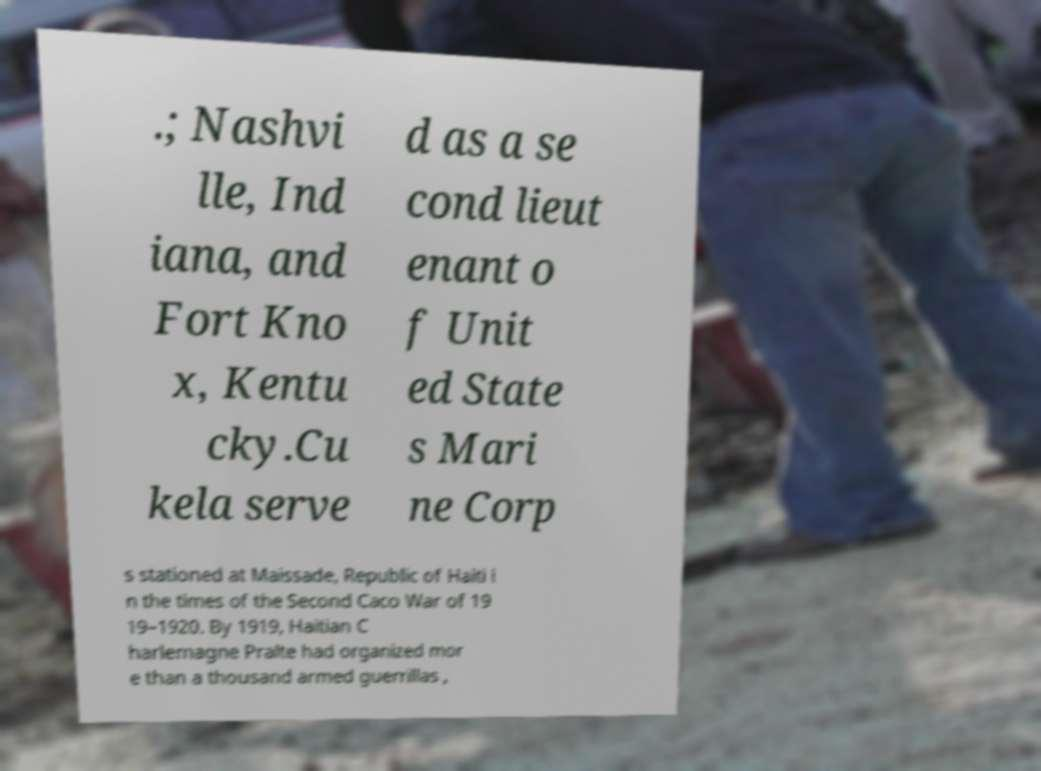Could you assist in decoding the text presented in this image and type it out clearly? .; Nashvi lle, Ind iana, and Fort Kno x, Kentu cky.Cu kela serve d as a se cond lieut enant o f Unit ed State s Mari ne Corp s stationed at Maissade, Republic of Haiti i n the times of the Second Caco War of 19 19–1920. By 1919, Haitian C harlemagne Pralte had organized mor e than a thousand armed guerrillas , 